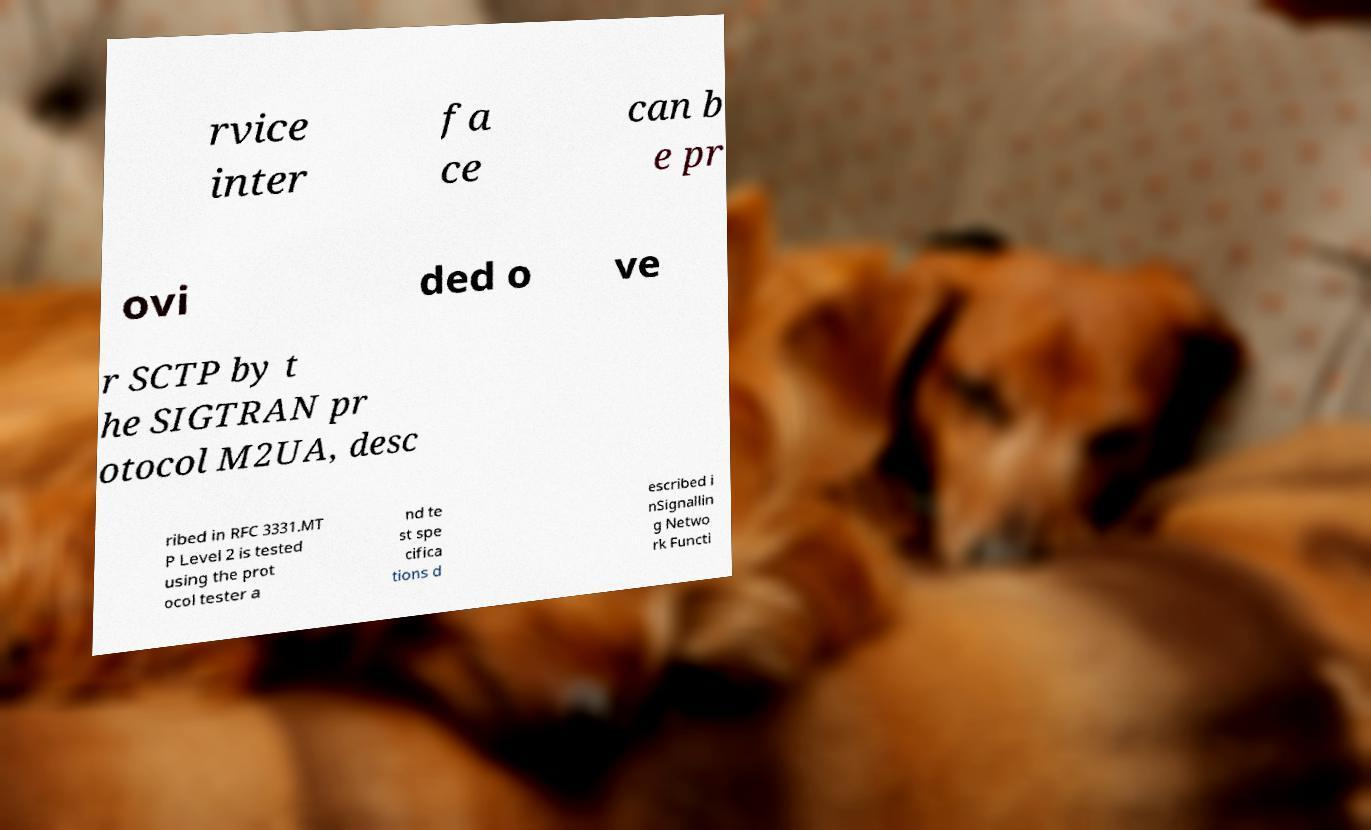There's text embedded in this image that I need extracted. Can you transcribe it verbatim? rvice inter fa ce can b e pr ovi ded o ve r SCTP by t he SIGTRAN pr otocol M2UA, desc ribed in RFC 3331.MT P Level 2 is tested using the prot ocol tester a nd te st spe cifica tions d escribed i nSignallin g Netwo rk Functi 